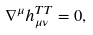Convert formula to latex. <formula><loc_0><loc_0><loc_500><loc_500>\nabla ^ { \mu } h _ { \mu \nu } ^ { T T } = 0 ,</formula> 